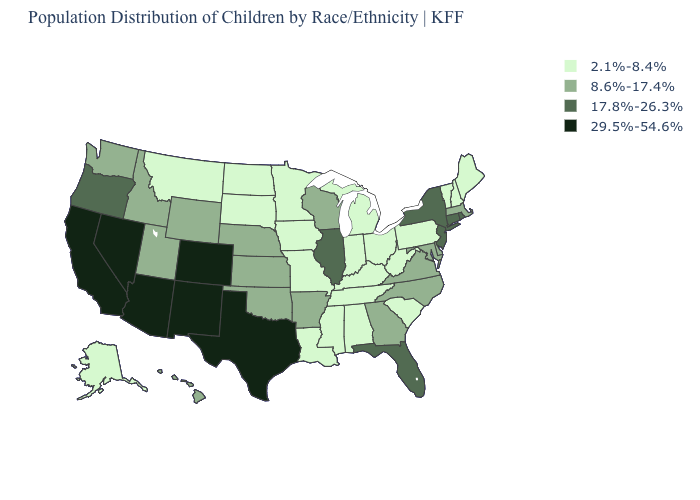Name the states that have a value in the range 29.5%-54.6%?
Concise answer only. Arizona, California, Colorado, Nevada, New Mexico, Texas. How many symbols are there in the legend?
Answer briefly. 4. What is the value of North Carolina?
Write a very short answer. 8.6%-17.4%. Among the states that border Virginia , which have the highest value?
Short answer required. Maryland, North Carolina. Name the states that have a value in the range 8.6%-17.4%?
Short answer required. Arkansas, Delaware, Georgia, Hawaii, Idaho, Kansas, Maryland, Massachusetts, Nebraska, North Carolina, Oklahoma, Utah, Virginia, Washington, Wisconsin, Wyoming. Is the legend a continuous bar?
Concise answer only. No. What is the value of New Mexico?
Keep it brief. 29.5%-54.6%. Does the first symbol in the legend represent the smallest category?
Be succinct. Yes. What is the lowest value in states that border Louisiana?
Answer briefly. 2.1%-8.4%. How many symbols are there in the legend?
Quick response, please. 4. Does Texas have the highest value in the South?
Short answer required. Yes. Among the states that border Idaho , which have the highest value?
Short answer required. Nevada. What is the lowest value in the MidWest?
Give a very brief answer. 2.1%-8.4%. Does the map have missing data?
Answer briefly. No. What is the value of South Carolina?
Write a very short answer. 2.1%-8.4%. 